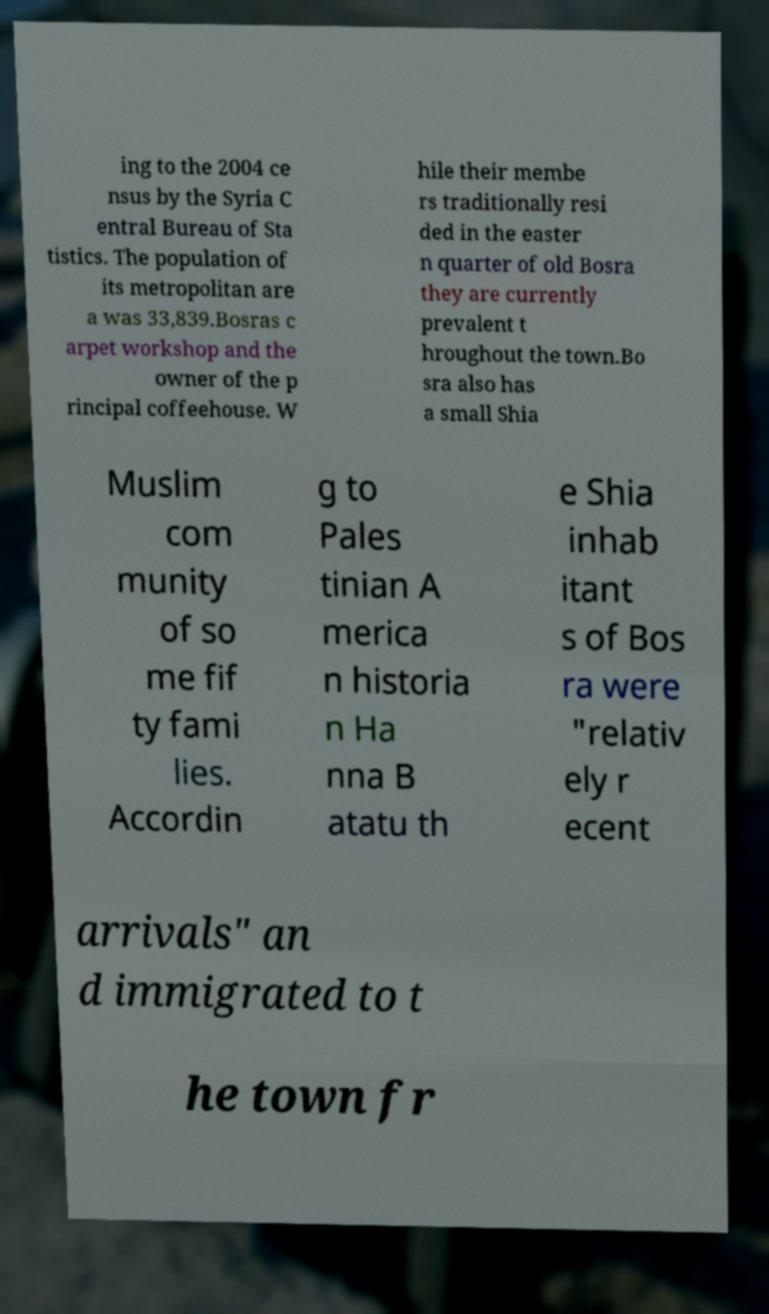Could you assist in decoding the text presented in this image and type it out clearly? ing to the 2004 ce nsus by the Syria C entral Bureau of Sta tistics. The population of its metropolitan are a was 33,839.Bosras c arpet workshop and the owner of the p rincipal coffeehouse. W hile their membe rs traditionally resi ded in the easter n quarter of old Bosra they are currently prevalent t hroughout the town.Bo sra also has a small Shia Muslim com munity of so me fif ty fami lies. Accordin g to Pales tinian A merica n historia n Ha nna B atatu th e Shia inhab itant s of Bos ra were "relativ ely r ecent arrivals" an d immigrated to t he town fr 